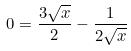Convert formula to latex. <formula><loc_0><loc_0><loc_500><loc_500>0 = \frac { 3 \sqrt { x } } { 2 } - \frac { 1 } { 2 \sqrt { x } }</formula> 